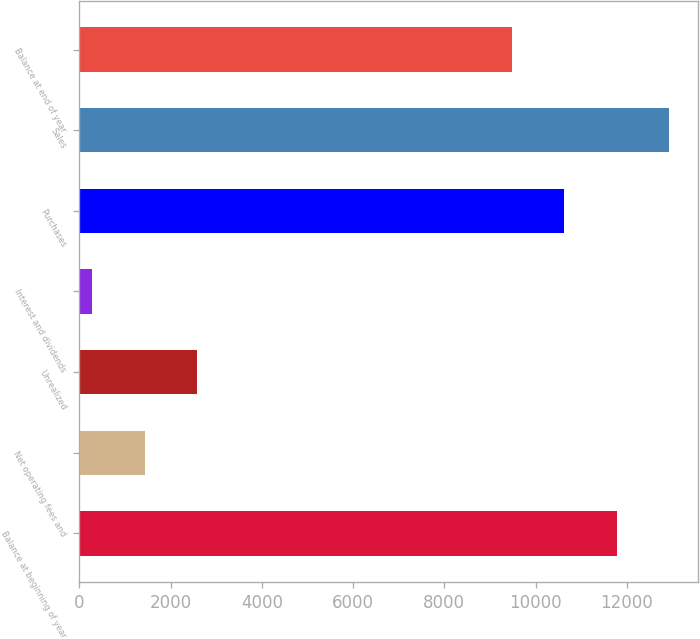Convert chart to OTSL. <chart><loc_0><loc_0><loc_500><loc_500><bar_chart><fcel>Balance at beginning of year<fcel>Net operating fees and<fcel>Unrealized<fcel>Interest and dividends<fcel>Purchases<fcel>Sales<fcel>Balance at end of year<nl><fcel>11775<fcel>1429.5<fcel>2575<fcel>284<fcel>10629.5<fcel>12920.5<fcel>9484<nl></chart> 